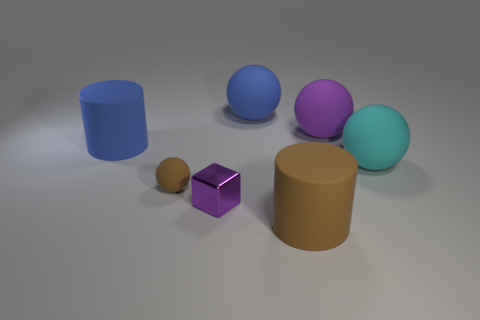How many blue spheres have the same size as the purple metallic cube?
Give a very brief answer. 0. Are there an equal number of blue things that are on the right side of the brown rubber sphere and cyan rubber balls?
Give a very brief answer. Yes. How many rubber objects are to the left of the tiny matte sphere and in front of the tiny metallic block?
Offer a very short reply. 0. Do the small brown object in front of the blue rubber sphere and the metal object have the same shape?
Provide a short and direct response. No. There is a blue cylinder that is the same size as the cyan object; what is it made of?
Your answer should be compact. Rubber. Is the number of cylinders that are in front of the purple metal cube the same as the number of small purple cubes that are in front of the brown cylinder?
Give a very brief answer. No. How many brown cylinders are on the left side of the rubber cylinder behind the big cylinder that is in front of the big blue matte cylinder?
Offer a very short reply. 0. Is the color of the metallic cube the same as the large object that is behind the big purple matte sphere?
Provide a succinct answer. No. What size is the other cylinder that is made of the same material as the large blue cylinder?
Provide a short and direct response. Large. Is the number of large blue balls on the right side of the cyan thing greater than the number of tiny rubber objects?
Your answer should be compact. No. 